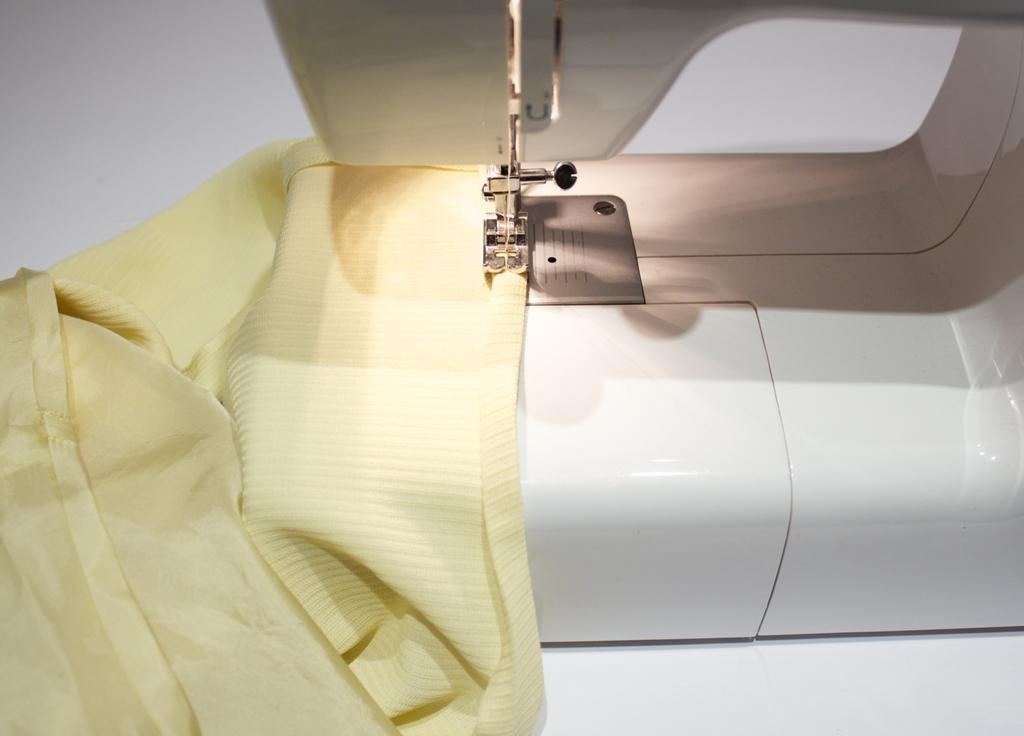What is the main object in the image? There is a sewing machine in the image. What is on top of the sewing machine? A cloth is placed on the surface of the sewing machine. Reasoning: Let's think step by identifying the main object in the image, which is the sewing machine. Then, we focus on the detail of the cloth placed on the sewing machine's surface. We formulate questions that are specific to the given facts and avoid any assumptions or speculation. Absurd Question/Answer: How many rabbits are jumping over the sewing machine in the image? There are no rabbits present in the image; it only features a sewing machine and a cloth. What type of sea creature can be seen swimming near the sewing machine in the image? There are no sea creatures, such as jellyfish, present in the image; it only features a sewing machine and a cloth. How many shelves are visible near the sewing machine in the image? There are no shelves present in the image; it only features a sewing machine and a cloth. 